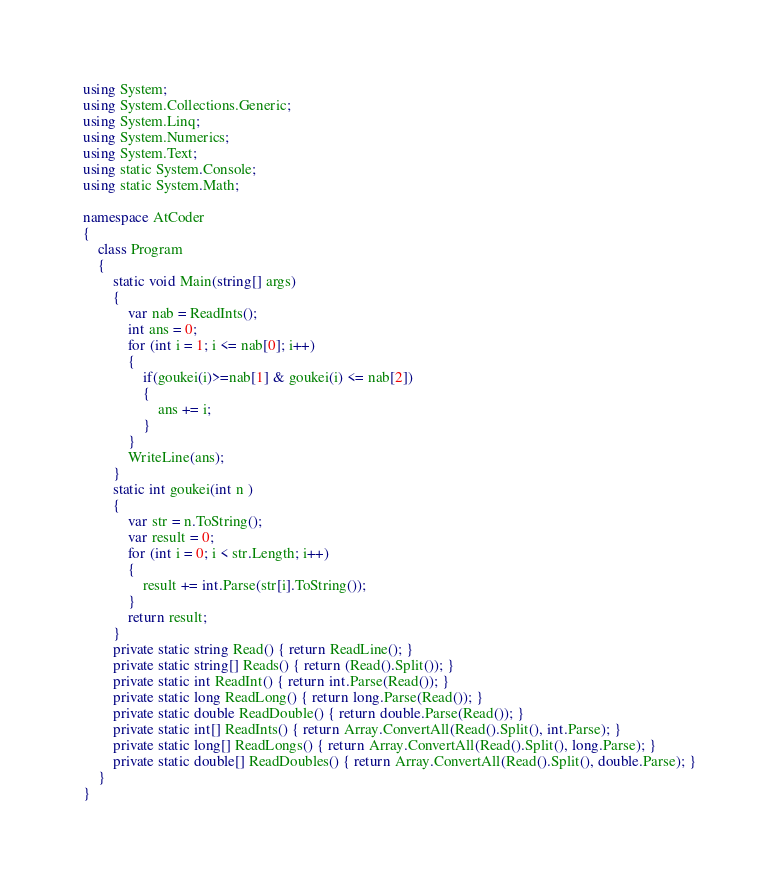Convert code to text. <code><loc_0><loc_0><loc_500><loc_500><_C#_>using System;
using System.Collections.Generic;
using System.Linq;
using System.Numerics;
using System.Text;
using static System.Console;
using static System.Math;

namespace AtCoder
{
    class Program
    {
        static void Main(string[] args)
        {
            var nab = ReadInts();
            int ans = 0;
            for (int i = 1; i <= nab[0]; i++)
            {
                if(goukei(i)>=nab[1] & goukei(i) <= nab[2])
                {
                    ans += i;
                }
            }
            WriteLine(ans);
        }
        static int goukei(int n )
        {
            var str = n.ToString();
            var result = 0;
            for (int i = 0; i < str.Length; i++)
            {
                result += int.Parse(str[i].ToString());
            }
            return result;
        }
        private static string Read() { return ReadLine(); }
        private static string[] Reads() { return (Read().Split()); }
        private static int ReadInt() { return int.Parse(Read()); }
        private static long ReadLong() { return long.Parse(Read()); }
        private static double ReadDouble() { return double.Parse(Read()); }
        private static int[] ReadInts() { return Array.ConvertAll(Read().Split(), int.Parse); }
        private static long[] ReadLongs() { return Array.ConvertAll(Read().Split(), long.Parse); }
        private static double[] ReadDoubles() { return Array.ConvertAll(Read().Split(), double.Parse); }
    }
}
</code> 